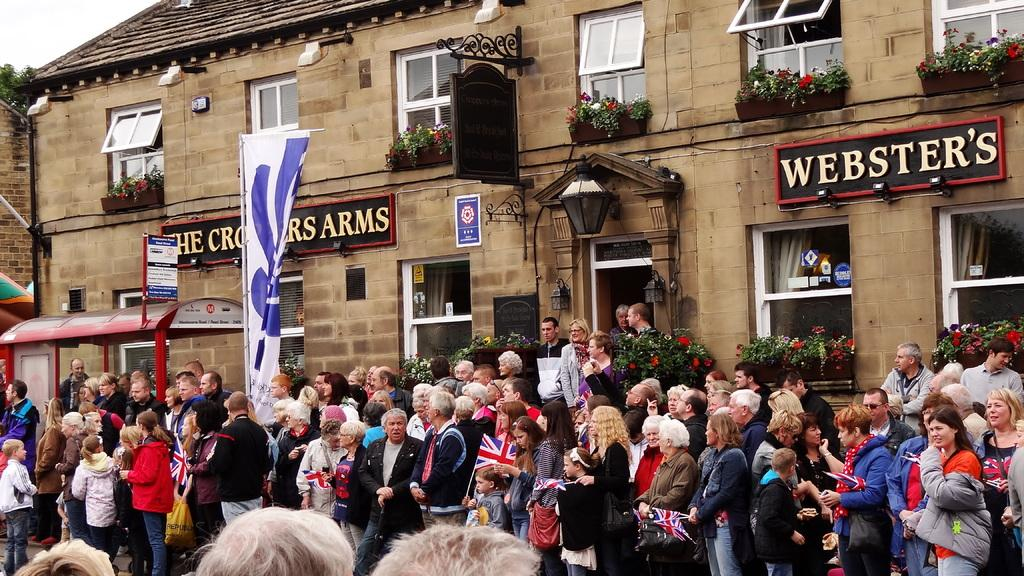What is happening in front of the building in the image? There are many people standing in front of the building. Can you describe the building in the image? The building has many windows. What can be seen hanging on the wall of the building? There is a flag hanging on the wall of the building. What is visible above the building in the image? The sky is visible above the building. What type of guide is standing on top of the building in the image? There is no guide or anyone standing on top of the building in the image. What sign is visible on the roof of the building in the image? There is no sign visible on the roof of the building in the image. 